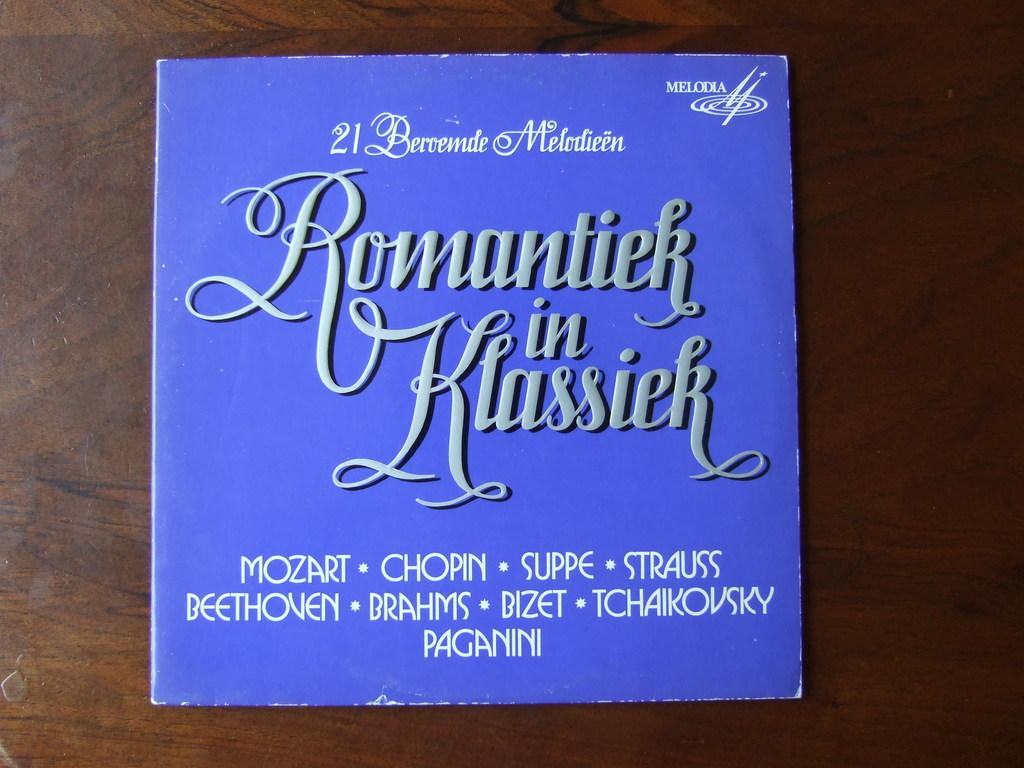Provide a one-sentence caption for the provided image. romantiek in klassiek mozark 21 beroende melodieen collection. 